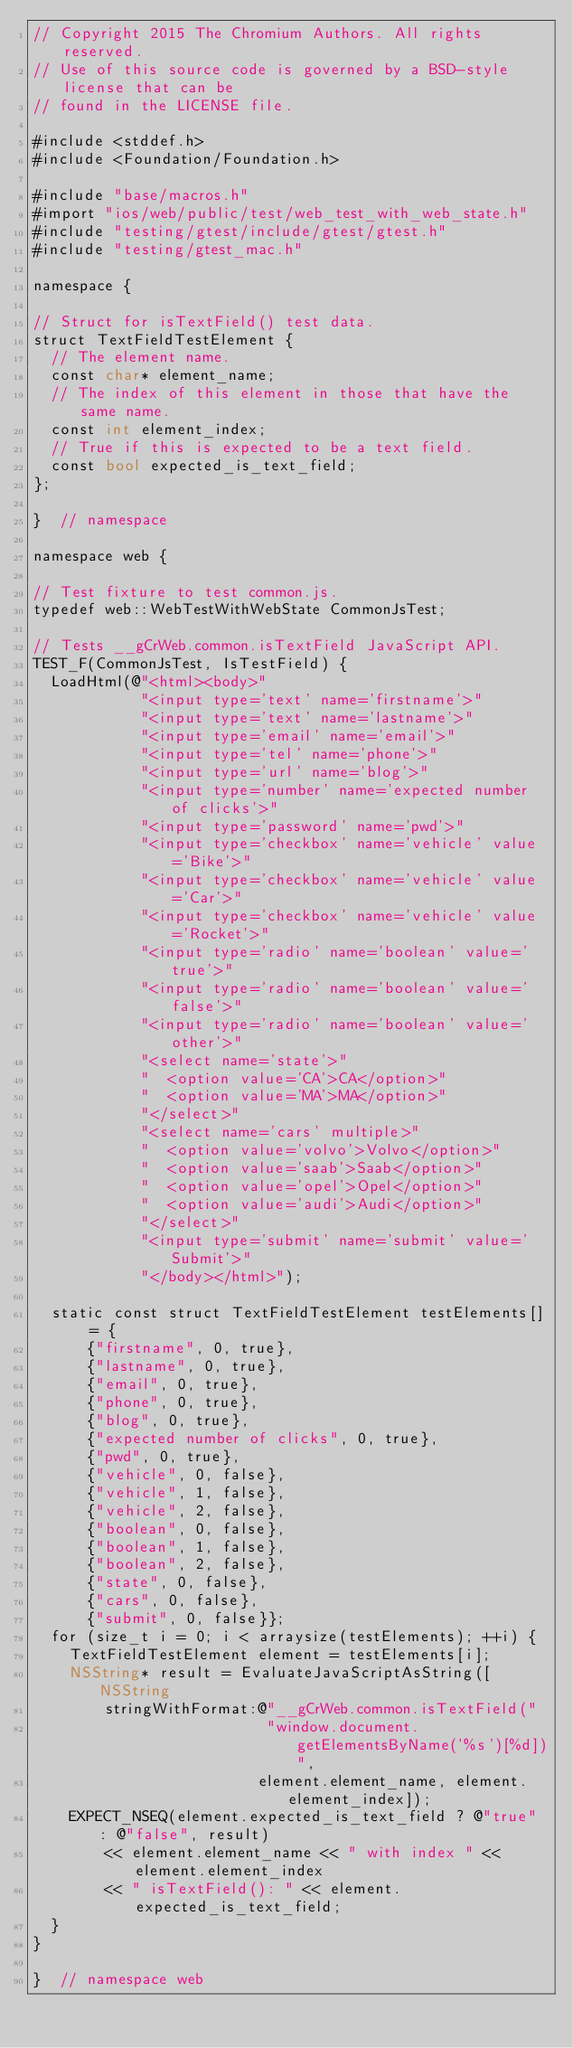<code> <loc_0><loc_0><loc_500><loc_500><_ObjectiveC_>// Copyright 2015 The Chromium Authors. All rights reserved.
// Use of this source code is governed by a BSD-style license that can be
// found in the LICENSE file.

#include <stddef.h>
#include <Foundation/Foundation.h>

#include "base/macros.h"
#import "ios/web/public/test/web_test_with_web_state.h"
#include "testing/gtest/include/gtest/gtest.h"
#include "testing/gtest_mac.h"

namespace {

// Struct for isTextField() test data.
struct TextFieldTestElement {
  // The element name.
  const char* element_name;
  // The index of this element in those that have the same name.
  const int element_index;
  // True if this is expected to be a text field.
  const bool expected_is_text_field;
};

}  // namespace

namespace web {

// Test fixture to test common.js.
typedef web::WebTestWithWebState CommonJsTest;

// Tests __gCrWeb.common.isTextField JavaScript API.
TEST_F(CommonJsTest, IsTestField) {
  LoadHtml(@"<html><body>"
            "<input type='text' name='firstname'>"
            "<input type='text' name='lastname'>"
            "<input type='email' name='email'>"
            "<input type='tel' name='phone'>"
            "<input type='url' name='blog'>"
            "<input type='number' name='expected number of clicks'>"
            "<input type='password' name='pwd'>"
            "<input type='checkbox' name='vehicle' value='Bike'>"
            "<input type='checkbox' name='vehicle' value='Car'>"
            "<input type='checkbox' name='vehicle' value='Rocket'>"
            "<input type='radio' name='boolean' value='true'>"
            "<input type='radio' name='boolean' value='false'>"
            "<input type='radio' name='boolean' value='other'>"
            "<select name='state'>"
            "  <option value='CA'>CA</option>"
            "  <option value='MA'>MA</option>"
            "</select>"
            "<select name='cars' multiple>"
            "  <option value='volvo'>Volvo</option>"
            "  <option value='saab'>Saab</option>"
            "  <option value='opel'>Opel</option>"
            "  <option value='audi'>Audi</option>"
            "</select>"
            "<input type='submit' name='submit' value='Submit'>"
            "</body></html>");

  static const struct TextFieldTestElement testElements[] = {
      {"firstname", 0, true},
      {"lastname", 0, true},
      {"email", 0, true},
      {"phone", 0, true},
      {"blog", 0, true},
      {"expected number of clicks", 0, true},
      {"pwd", 0, true},
      {"vehicle", 0, false},
      {"vehicle", 1, false},
      {"vehicle", 2, false},
      {"boolean", 0, false},
      {"boolean", 1, false},
      {"boolean", 2, false},
      {"state", 0, false},
      {"cars", 0, false},
      {"submit", 0, false}};
  for (size_t i = 0; i < arraysize(testElements); ++i) {
    TextFieldTestElement element = testElements[i];
    NSString* result = EvaluateJavaScriptAsString([NSString
        stringWithFormat:@"__gCrWeb.common.isTextField("
                          "window.document.getElementsByName('%s')[%d])",
                         element.element_name, element.element_index]);
    EXPECT_NSEQ(element.expected_is_text_field ? @"true" : @"false", result)
        << element.element_name << " with index " << element.element_index
        << " isTextField(): " << element.expected_is_text_field;
  }
}

}  // namespace web
</code> 